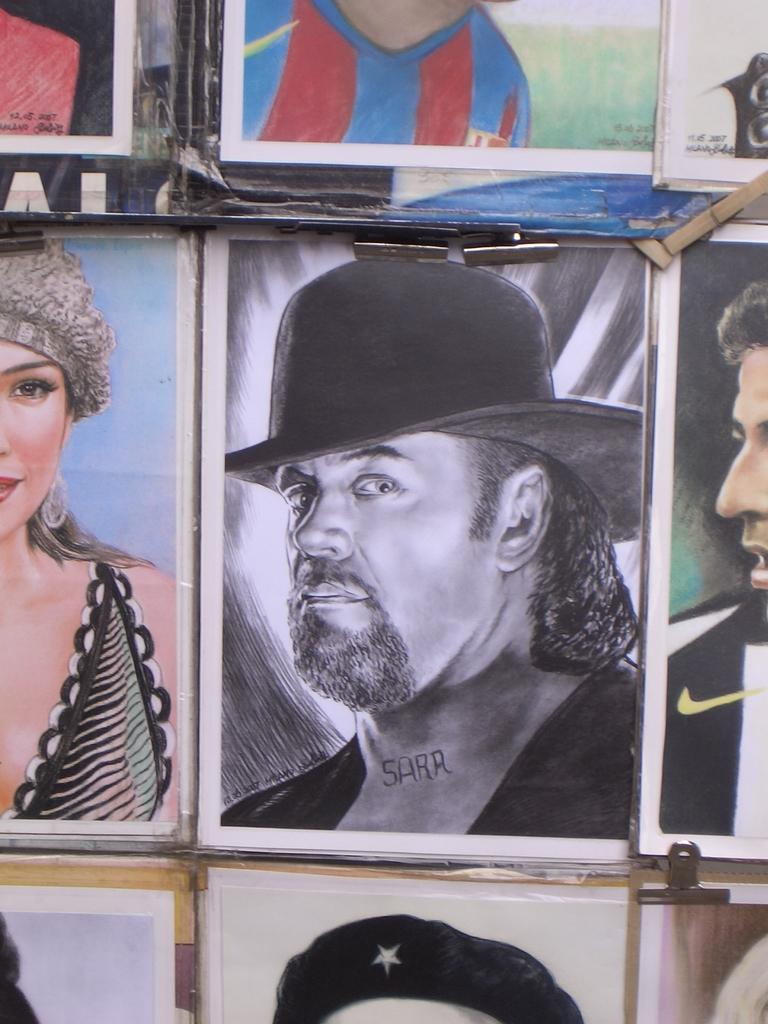What objects are present in the image that hold photographs? There are photo frames in the image. What can be seen inside the photo frames? The photo frames contain images of a person. What type of attraction can be seen in the image? There is no attraction present in the image; it features photo frames with images of a person. What is the purpose of the tub in the image? There is no tub present in the image. 